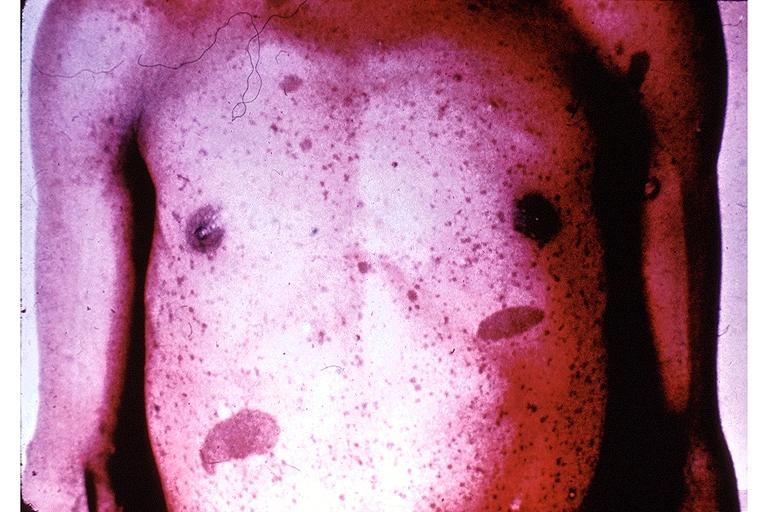where is this?
Answer the question using a single word or phrase. Skin 